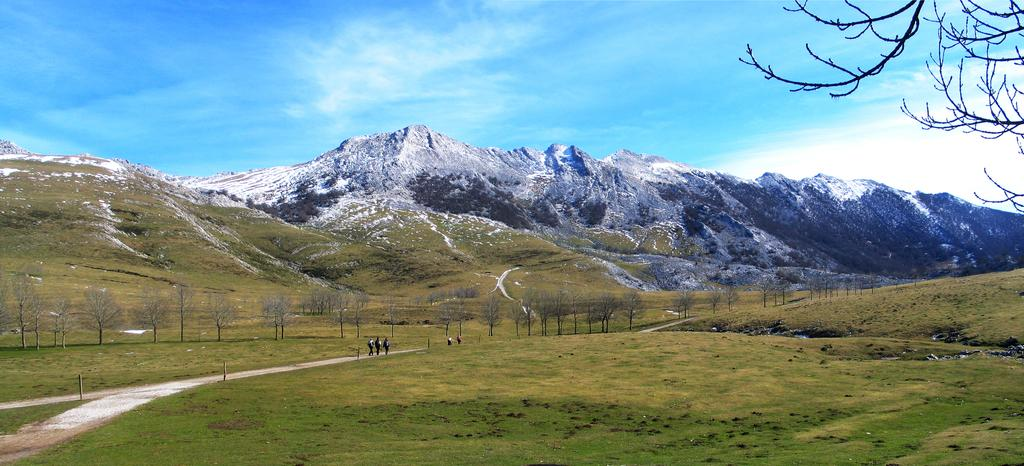What type of landscape is depicted in the image? The image features hills. What can be seen at the bottom of the hills? There are trees at the bottom of the image. Are there any living beings visible in the image? Yes, there are people visible in the image. What is visible in the background of the image? The sky is visible in the background of the image. Can you tell me how many times the ground has been bitten by the people in the image? There is no indication in the image that the ground has been bitten by anyone. How do the people in the image fly to the top of the hills? The people in the image are not shown flying; they are likely walking or climbing to reach the top of the hills. 